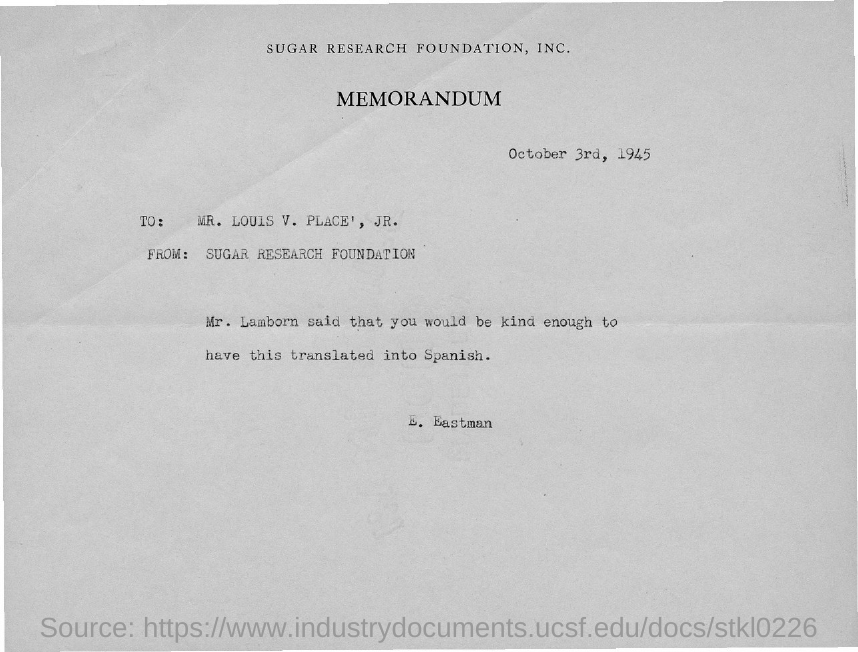What type of communication is this?
Keep it short and to the point. MEMORANDUM. What is the date mentioned in the memorandum?
Ensure brevity in your answer.  October 3rd, 1945. Which company is mentioned in the header of the document?
Give a very brief answer. Sugar Research Foundation, Inc. Who is the sender of this memorandum?
Your answer should be compact. Sugar Research Foundation. Who is the addressee of this memorandum?
Your answer should be very brief. Louis V. Place', JR. 